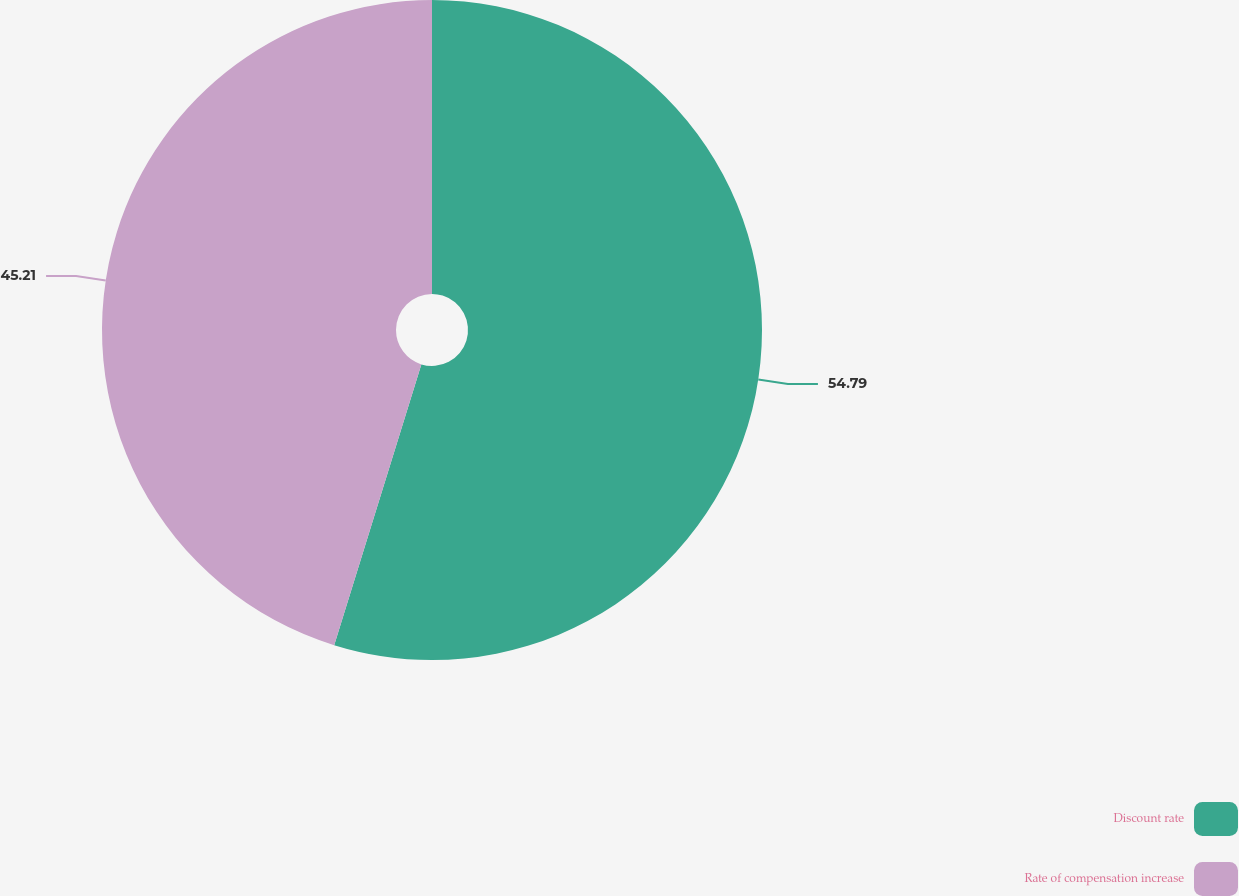<chart> <loc_0><loc_0><loc_500><loc_500><pie_chart><fcel>Discount rate<fcel>Rate of compensation increase<nl><fcel>54.79%<fcel>45.21%<nl></chart> 